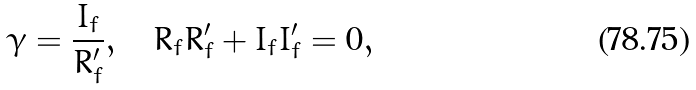Convert formula to latex. <formula><loc_0><loc_0><loc_500><loc_500>\gamma = \frac { I _ { f } } { R ^ { \prime } _ { f } } , \quad R _ { f } R ^ { \prime } _ { f } + I _ { f } I ^ { \prime } _ { f } = 0 ,</formula> 